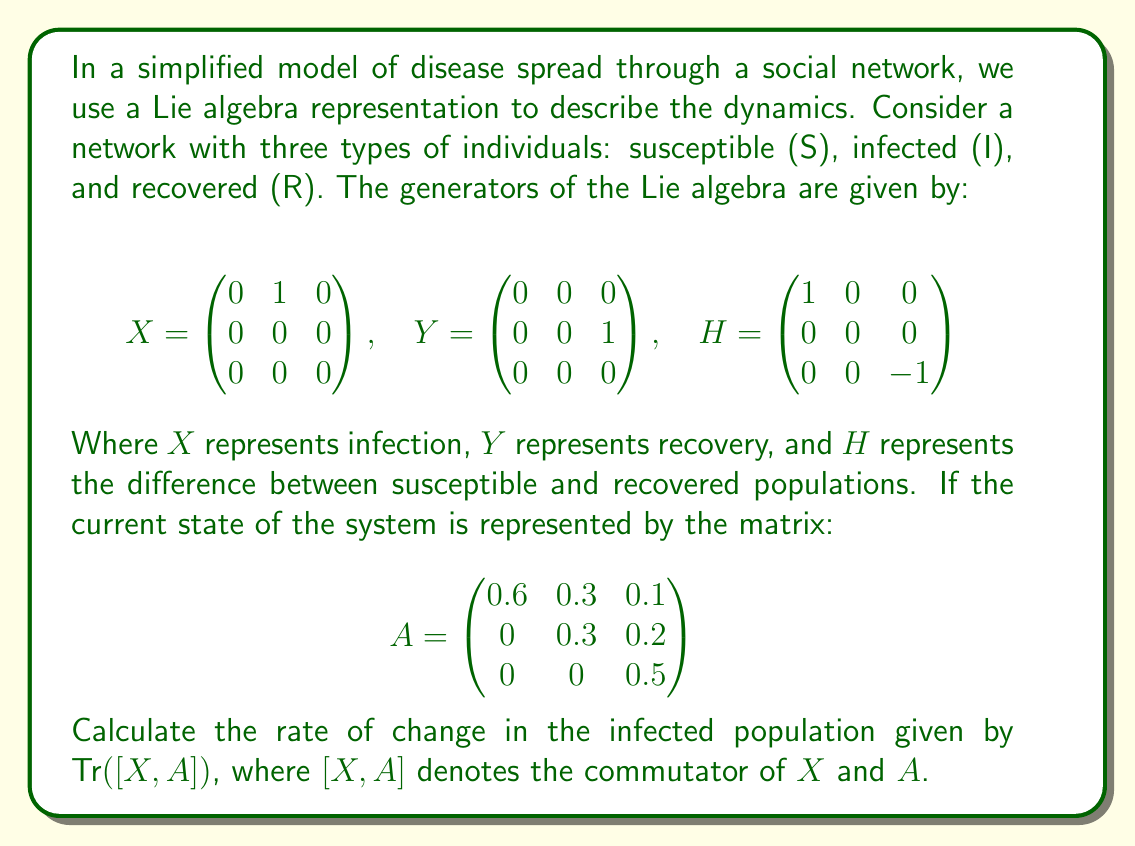What is the answer to this math problem? To solve this problem, we need to follow these steps:

1) First, recall that the commutator $[X, A]$ is defined as $XA - AX$.

2) Calculate $XA$:
   $$XA = \begin{pmatrix} 0 & 1 & 0 \\ 0 & 0 & 0 \\ 0 & 0 & 0 \end{pmatrix} \begin{pmatrix} 0.6 & 0.3 & 0.1 \\ 0 & 0.3 & 0.2 \\ 0 & 0 & 0.5 \end{pmatrix} = \begin{pmatrix} 0 & 0.3 & 0.2 \\ 0 & 0 & 0 \\ 0 & 0 & 0 \end{pmatrix}$$

3) Calculate $AX$:
   $$AX = \begin{pmatrix} 0.6 & 0.3 & 0.1 \\ 0 & 0.3 & 0.2 \\ 0 & 0 & 0.5 \end{pmatrix} \begin{pmatrix} 0 & 1 & 0 \\ 0 & 0 & 0 \\ 0 & 0 & 0 \end{pmatrix} = \begin{pmatrix} 0 & 0.6 & 0 \\ 0 & 0 & 0 \\ 0 & 0 & 0 \end{pmatrix}$$

4) Calculate $[X, A] = XA - AX$:
   $$[X, A] = \begin{pmatrix} 0 & 0.3 & 0.2 \\ 0 & 0 & 0 \\ 0 & 0 & 0 \end{pmatrix} - \begin{pmatrix} 0 & 0.6 & 0 \\ 0 & 0 & 0 \\ 0 & 0 & 0 \end{pmatrix} = \begin{pmatrix} 0 & -0.3 & 0.2 \\ 0 & 0 & 0 \\ 0 & 0 & 0 \end{pmatrix}$$

5) The trace of a matrix is the sum of its diagonal elements. Therefore:
   $$\text{Tr}([X, A]) = 0 + 0 + 0 = 0$$

In the context of our model, this result indicates that the rate of change in the infected population is zero at this particular state. This suggests that the system is at an equilibrium point where the rate of new infections equals the rate of recoveries.
Answer: $\text{Tr}([X, A]) = 0$ 